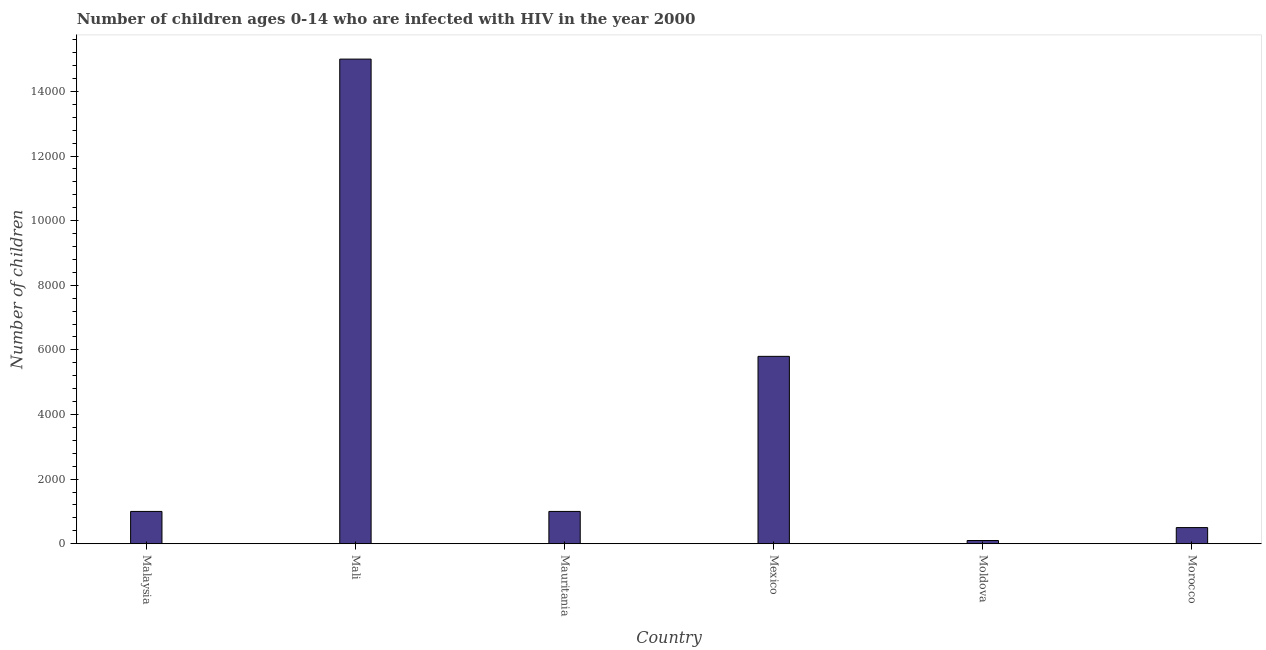What is the title of the graph?
Your response must be concise. Number of children ages 0-14 who are infected with HIV in the year 2000. What is the label or title of the X-axis?
Your answer should be compact. Country. What is the label or title of the Y-axis?
Your answer should be compact. Number of children. What is the number of children living with hiv in Mauritania?
Offer a terse response. 1000. Across all countries, what is the maximum number of children living with hiv?
Ensure brevity in your answer.  1.50e+04. In which country was the number of children living with hiv maximum?
Provide a succinct answer. Mali. In which country was the number of children living with hiv minimum?
Keep it short and to the point. Moldova. What is the sum of the number of children living with hiv?
Provide a short and direct response. 2.34e+04. What is the difference between the number of children living with hiv in Malaysia and Mexico?
Offer a very short reply. -4800. What is the average number of children living with hiv per country?
Keep it short and to the point. 3900. In how many countries, is the number of children living with hiv greater than 11600 ?
Make the answer very short. 1. What is the ratio of the number of children living with hiv in Mexico to that in Morocco?
Offer a terse response. 11.6. What is the difference between the highest and the second highest number of children living with hiv?
Ensure brevity in your answer.  9200. Is the sum of the number of children living with hiv in Mali and Mauritania greater than the maximum number of children living with hiv across all countries?
Make the answer very short. Yes. What is the difference between the highest and the lowest number of children living with hiv?
Provide a short and direct response. 1.49e+04. In how many countries, is the number of children living with hiv greater than the average number of children living with hiv taken over all countries?
Provide a short and direct response. 2. Are all the bars in the graph horizontal?
Your answer should be compact. No. How many countries are there in the graph?
Your response must be concise. 6. What is the Number of children of Mali?
Your answer should be compact. 1.50e+04. What is the Number of children of Mauritania?
Provide a short and direct response. 1000. What is the Number of children in Mexico?
Ensure brevity in your answer.  5800. What is the Number of children of Morocco?
Your response must be concise. 500. What is the difference between the Number of children in Malaysia and Mali?
Offer a very short reply. -1.40e+04. What is the difference between the Number of children in Malaysia and Mexico?
Your response must be concise. -4800. What is the difference between the Number of children in Malaysia and Moldova?
Your answer should be compact. 900. What is the difference between the Number of children in Mali and Mauritania?
Offer a very short reply. 1.40e+04. What is the difference between the Number of children in Mali and Mexico?
Your response must be concise. 9200. What is the difference between the Number of children in Mali and Moldova?
Ensure brevity in your answer.  1.49e+04. What is the difference between the Number of children in Mali and Morocco?
Offer a very short reply. 1.45e+04. What is the difference between the Number of children in Mauritania and Mexico?
Offer a terse response. -4800. What is the difference between the Number of children in Mauritania and Moldova?
Make the answer very short. 900. What is the difference between the Number of children in Mauritania and Morocco?
Offer a very short reply. 500. What is the difference between the Number of children in Mexico and Moldova?
Offer a very short reply. 5700. What is the difference between the Number of children in Mexico and Morocco?
Offer a terse response. 5300. What is the difference between the Number of children in Moldova and Morocco?
Your answer should be compact. -400. What is the ratio of the Number of children in Malaysia to that in Mali?
Offer a terse response. 0.07. What is the ratio of the Number of children in Malaysia to that in Mexico?
Provide a succinct answer. 0.17. What is the ratio of the Number of children in Malaysia to that in Moldova?
Give a very brief answer. 10. What is the ratio of the Number of children in Malaysia to that in Morocco?
Give a very brief answer. 2. What is the ratio of the Number of children in Mali to that in Mauritania?
Ensure brevity in your answer.  15. What is the ratio of the Number of children in Mali to that in Mexico?
Ensure brevity in your answer.  2.59. What is the ratio of the Number of children in Mali to that in Moldova?
Offer a very short reply. 150. What is the ratio of the Number of children in Mali to that in Morocco?
Offer a terse response. 30. What is the ratio of the Number of children in Mauritania to that in Mexico?
Ensure brevity in your answer.  0.17. What is the ratio of the Number of children in Mauritania to that in Moldova?
Your answer should be compact. 10. What is the ratio of the Number of children in Mauritania to that in Morocco?
Make the answer very short. 2. What is the ratio of the Number of children in Mexico to that in Moldova?
Your response must be concise. 58. What is the ratio of the Number of children in Mexico to that in Morocco?
Your answer should be compact. 11.6. What is the ratio of the Number of children in Moldova to that in Morocco?
Make the answer very short. 0.2. 